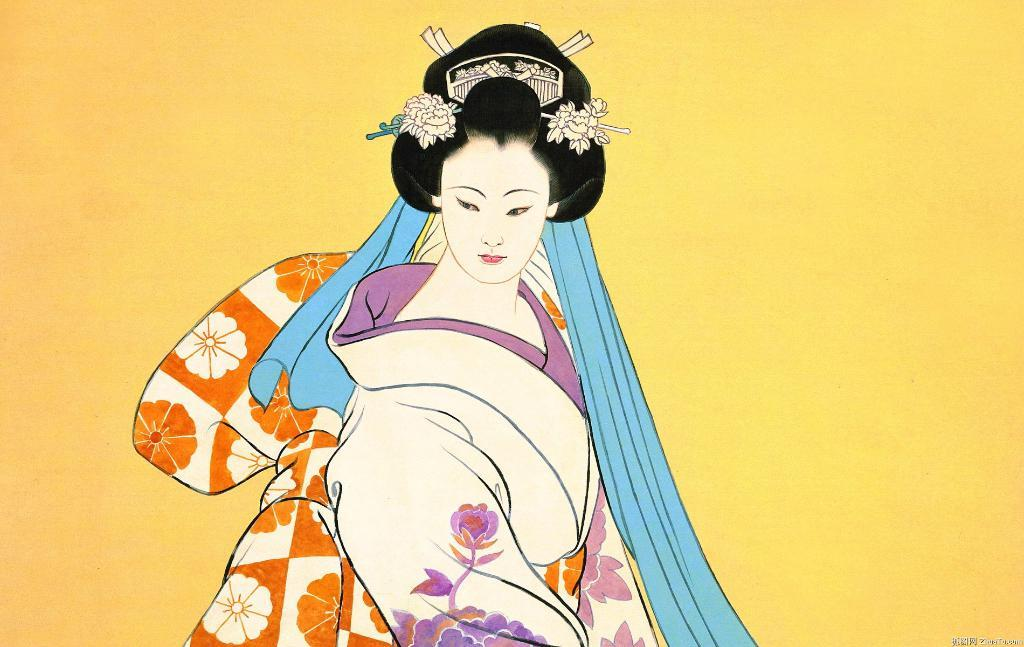What is depicted in the image? There is a drawing of a woman in the image. What is the woman wearing in the drawing? The woman is wearing a white dress in the drawing. What color is the prominent object in the image? There is a blue color thing in the image. What is the color of the background in the image? The background of the image is yellow. Can you tell me how many times the woman sneezes in the image? There is no indication of the woman sneezing in the image; it is a drawing of a woman wearing a white dress with a blue object and a yellow background. 